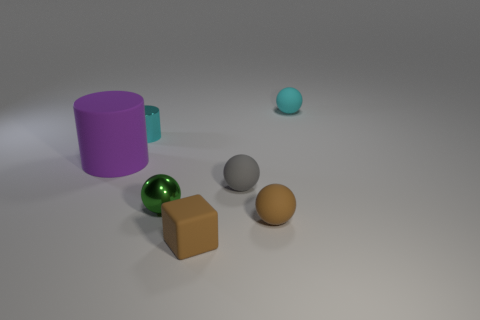Is there anything else that is the same size as the purple matte thing?
Provide a succinct answer. No. Are there any other things that are the same material as the small cylinder?
Provide a succinct answer. Yes. What number of objects are on the left side of the tiny cyan matte object and behind the gray rubber ball?
Make the answer very short. 2. How many objects are either cyan shiny cylinders right of the purple rubber cylinder or big cylinders on the left side of the green ball?
Make the answer very short. 2. What number of other objects are there of the same shape as the gray matte object?
Your response must be concise. 3. Is the color of the rubber ball in front of the small green ball the same as the small cube?
Ensure brevity in your answer.  Yes. How many other objects are there of the same size as the cyan metal thing?
Keep it short and to the point. 5. Does the big cylinder have the same material as the gray ball?
Make the answer very short. Yes. The matte sphere behind the tiny shiny thing behind the purple rubber cylinder is what color?
Offer a very short reply. Cyan. There is a cyan metallic object that is the same shape as the purple rubber thing; what is its size?
Your response must be concise. Small. 